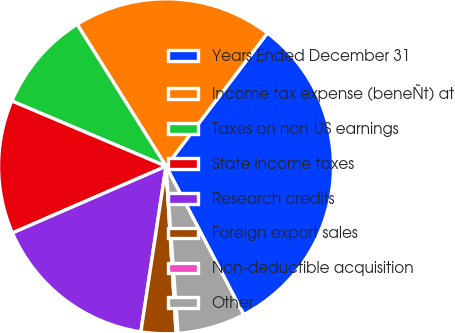<chart> <loc_0><loc_0><loc_500><loc_500><pie_chart><fcel>Years Ended December 31<fcel>Income tax expense (beneÑt) at<fcel>Taxes on non-US earnings<fcel>State income taxes<fcel>Research credits<fcel>Foreign export sales<fcel>Non-deductible acquisition<fcel>Other<nl><fcel>31.98%<fcel>19.26%<fcel>9.72%<fcel>12.9%<fcel>16.08%<fcel>3.36%<fcel>0.18%<fcel>6.54%<nl></chart> 